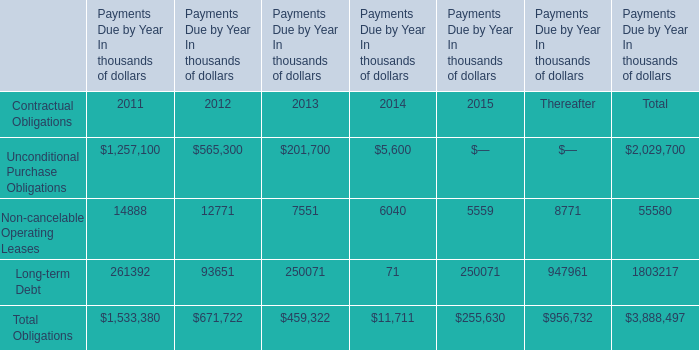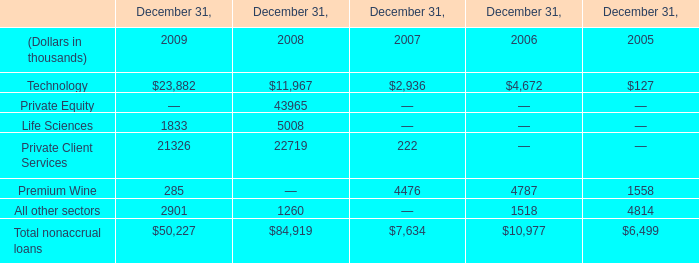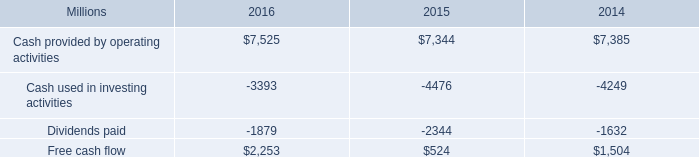What's the average of Technology of December 31, 2006, and Cash provided by operating activities of 2016 ? 
Computations: ((4672.0 + 7525.0) / 2)
Answer: 6098.5. 